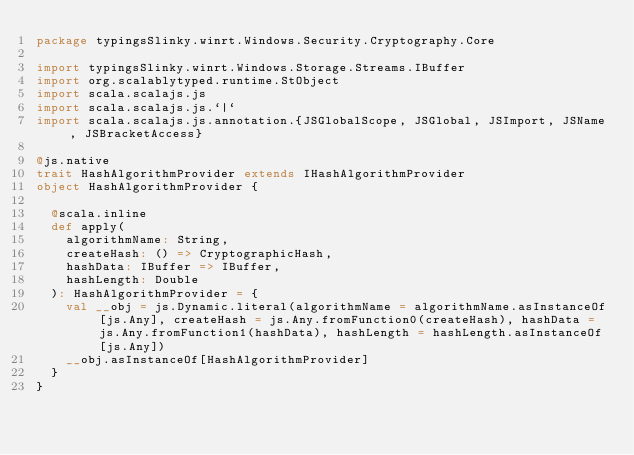Convert code to text. <code><loc_0><loc_0><loc_500><loc_500><_Scala_>package typingsSlinky.winrt.Windows.Security.Cryptography.Core

import typingsSlinky.winrt.Windows.Storage.Streams.IBuffer
import org.scalablytyped.runtime.StObject
import scala.scalajs.js
import scala.scalajs.js.`|`
import scala.scalajs.js.annotation.{JSGlobalScope, JSGlobal, JSImport, JSName, JSBracketAccess}

@js.native
trait HashAlgorithmProvider extends IHashAlgorithmProvider
object HashAlgorithmProvider {
  
  @scala.inline
  def apply(
    algorithmName: String,
    createHash: () => CryptographicHash,
    hashData: IBuffer => IBuffer,
    hashLength: Double
  ): HashAlgorithmProvider = {
    val __obj = js.Dynamic.literal(algorithmName = algorithmName.asInstanceOf[js.Any], createHash = js.Any.fromFunction0(createHash), hashData = js.Any.fromFunction1(hashData), hashLength = hashLength.asInstanceOf[js.Any])
    __obj.asInstanceOf[HashAlgorithmProvider]
  }
}
</code> 